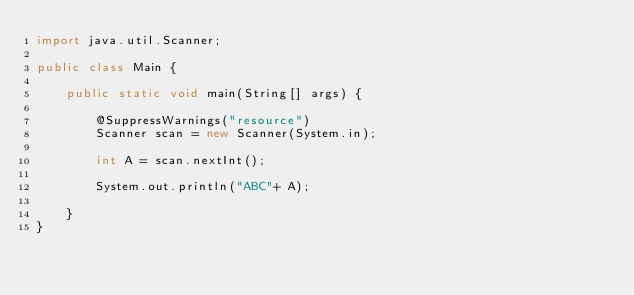<code> <loc_0><loc_0><loc_500><loc_500><_Java_>import java.util.Scanner;

public class Main {

	public static void main(String[] args) {

		@SuppressWarnings("resource")
		Scanner scan = new Scanner(System.in);

		int A = scan.nextInt();
		
		System.out.println("ABC"+ A);

	}
}</code> 